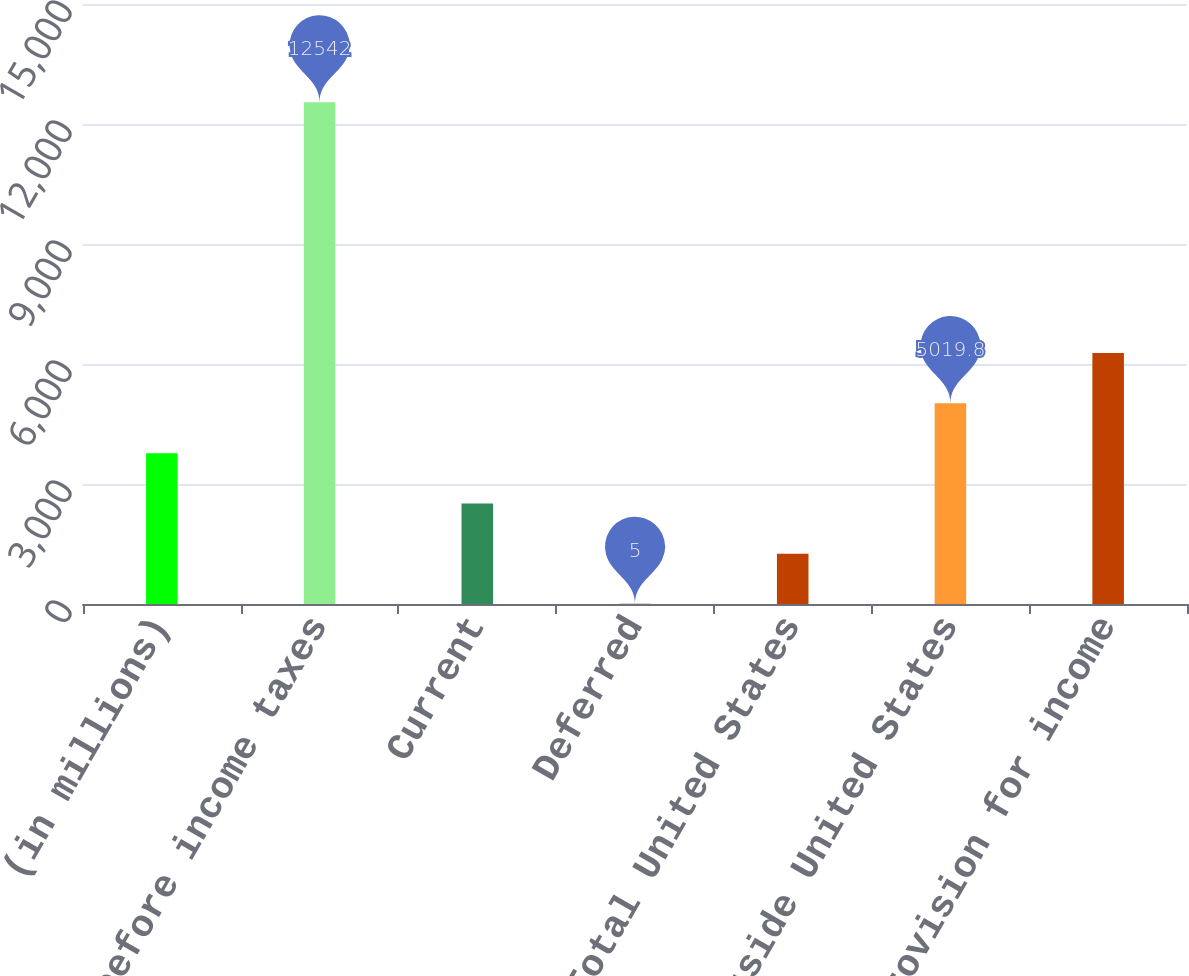<chart> <loc_0><loc_0><loc_500><loc_500><bar_chart><fcel>(in millions)<fcel>Earnings before income taxes<fcel>Current<fcel>Deferred<fcel>Total United States<fcel>Total outside United States<fcel>Total provision for income<nl><fcel>3766.1<fcel>12542<fcel>2512.4<fcel>5<fcel>1258.7<fcel>5019.8<fcel>6273.5<nl></chart> 